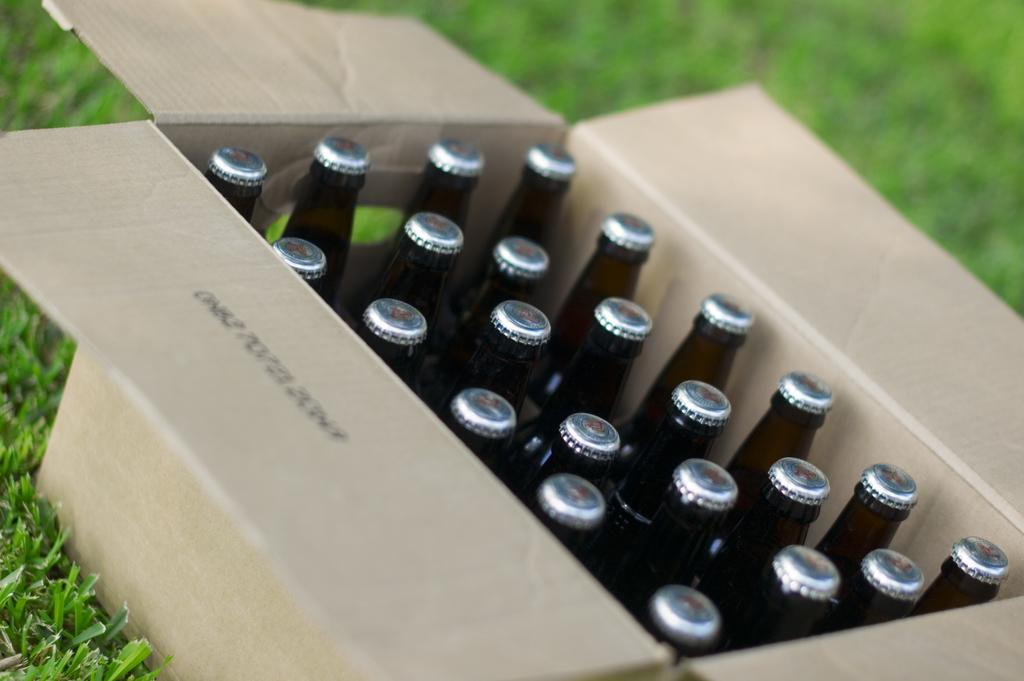What objects are present in the image? There are bottles in the image. Where are the bottles located? The bottles are in a box. What is the surface on which the box is placed? The box is on the grass. What type of pie is being served on the grass in the image? There is no pie present in the image; it features bottles in a box on the grass. 